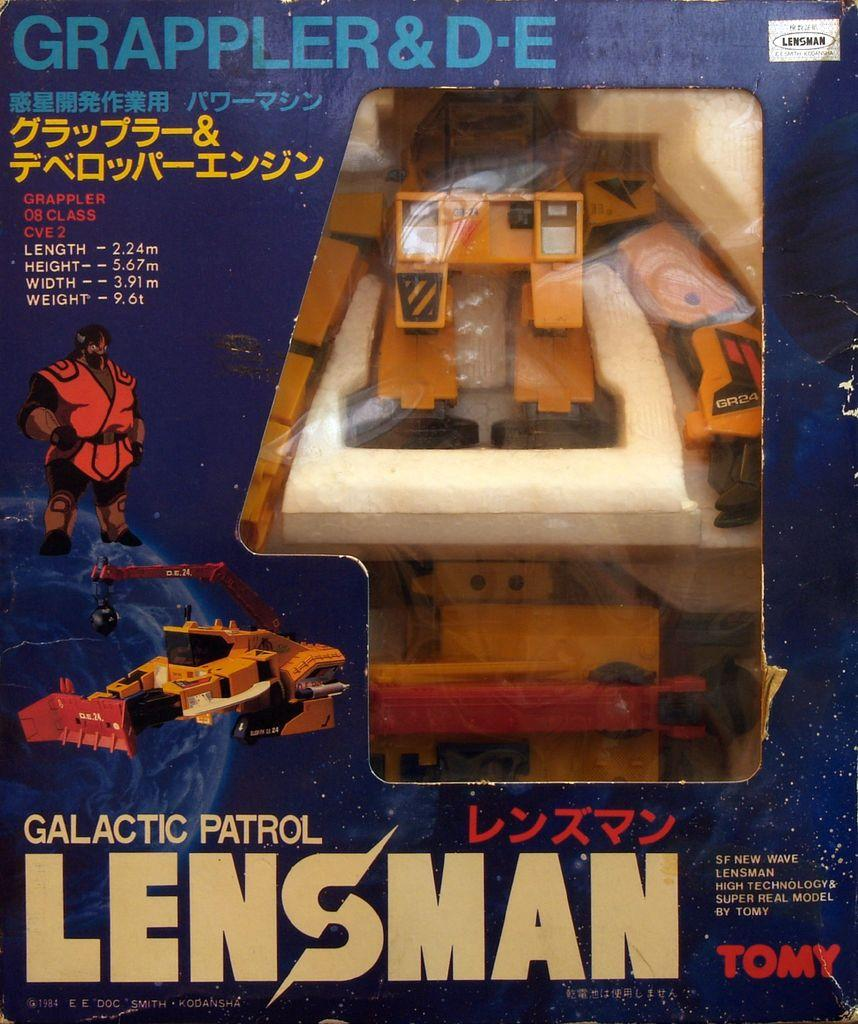<image>
Offer a succinct explanation of the picture presented. the word lensman that is on a magazine 